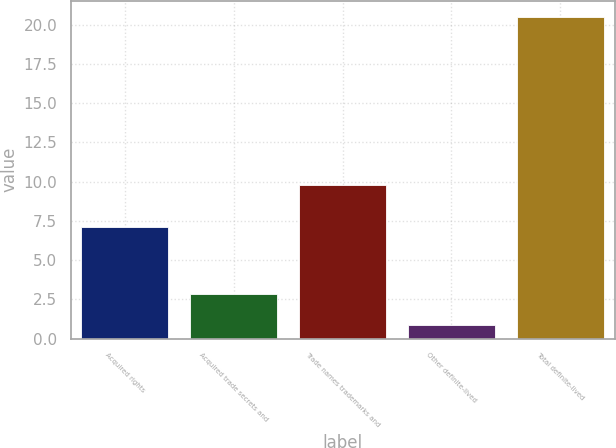Convert chart. <chart><loc_0><loc_0><loc_500><loc_500><bar_chart><fcel>Acquired rights<fcel>Acquired trade secrets and<fcel>Trade names trademarks and<fcel>Other definite-lived<fcel>Total definite-lived<nl><fcel>7.1<fcel>2.86<fcel>9.8<fcel>0.9<fcel>20.5<nl></chart> 